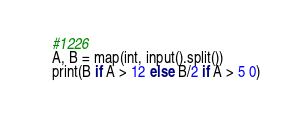Convert code to text. <code><loc_0><loc_0><loc_500><loc_500><_Python_>#1226
A, B = map(int, input().split())
print(B if A > 12 else B/2 if A > 5 0)</code> 